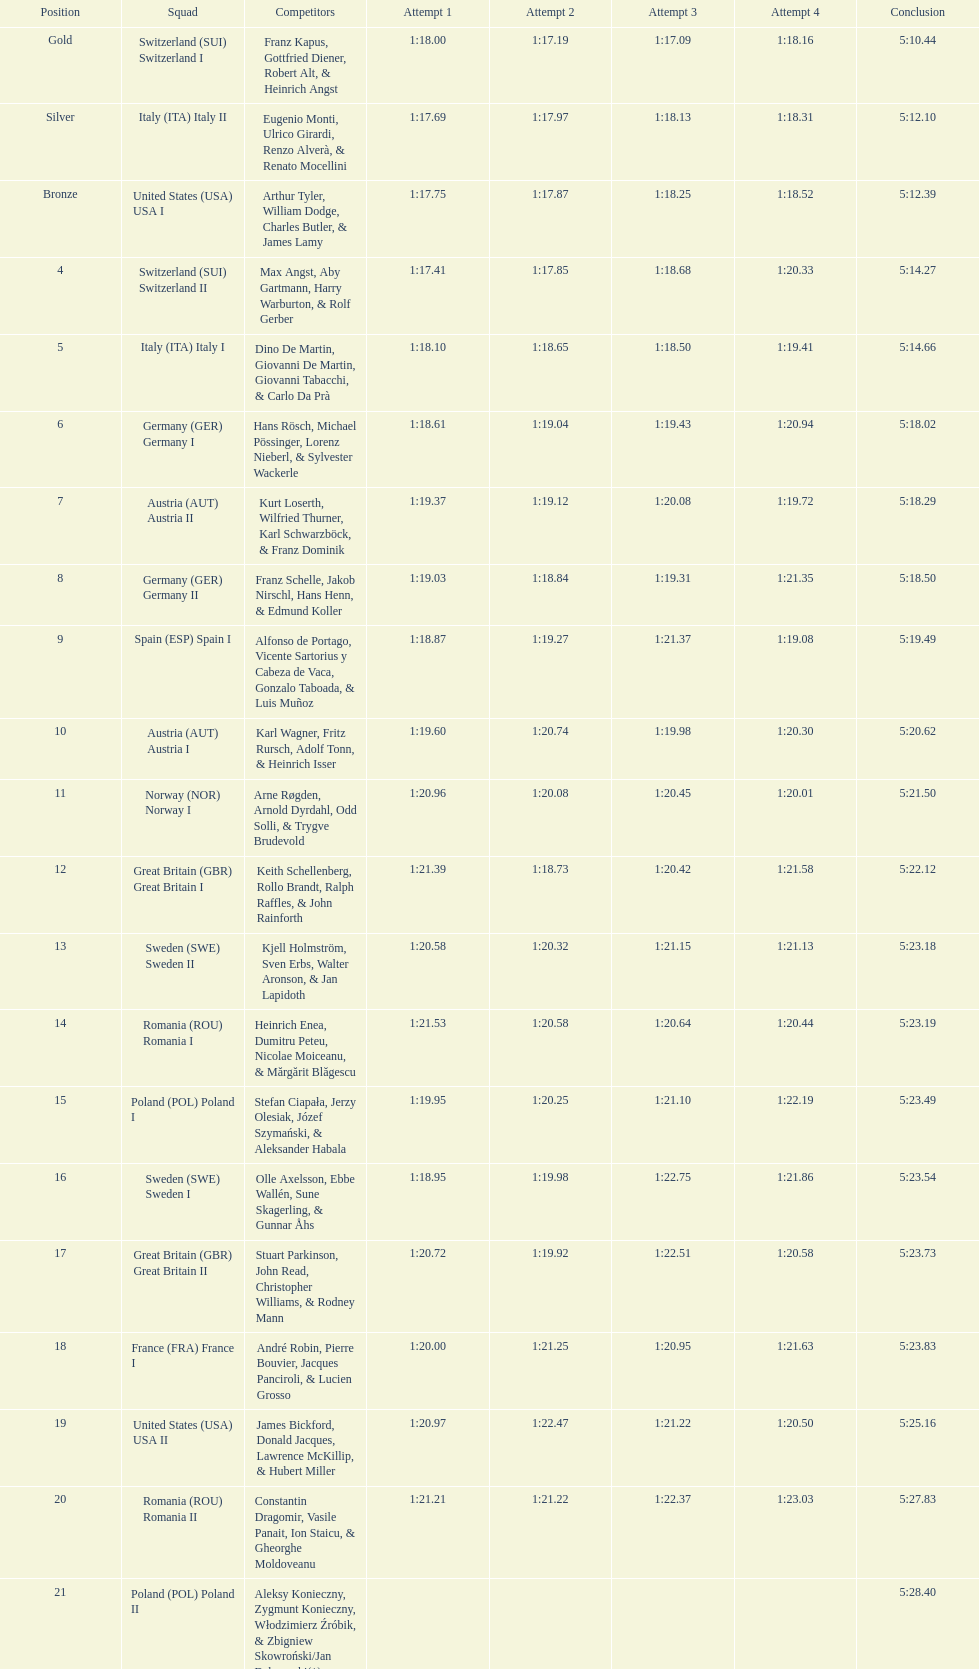Who is the previous team to italy (ita) italy ii? Switzerland (SUI) Switzerland I. 